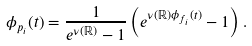<formula> <loc_0><loc_0><loc_500><loc_500>\phi _ { p _ { i } } ( t ) = \frac { 1 } { e ^ { \nu ( \mathbb { R } ) } - 1 } \left ( e ^ { \nu ( \mathbb { R } ) \phi _ { f _ { i } } ( t ) } - 1 \right ) .</formula> 